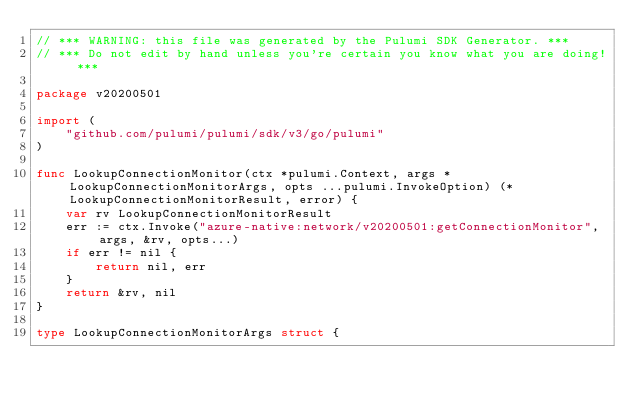<code> <loc_0><loc_0><loc_500><loc_500><_Go_>// *** WARNING: this file was generated by the Pulumi SDK Generator. ***
// *** Do not edit by hand unless you're certain you know what you are doing! ***

package v20200501

import (
	"github.com/pulumi/pulumi/sdk/v3/go/pulumi"
)

func LookupConnectionMonitor(ctx *pulumi.Context, args *LookupConnectionMonitorArgs, opts ...pulumi.InvokeOption) (*LookupConnectionMonitorResult, error) {
	var rv LookupConnectionMonitorResult
	err := ctx.Invoke("azure-native:network/v20200501:getConnectionMonitor", args, &rv, opts...)
	if err != nil {
		return nil, err
	}
	return &rv, nil
}

type LookupConnectionMonitorArgs struct {</code> 